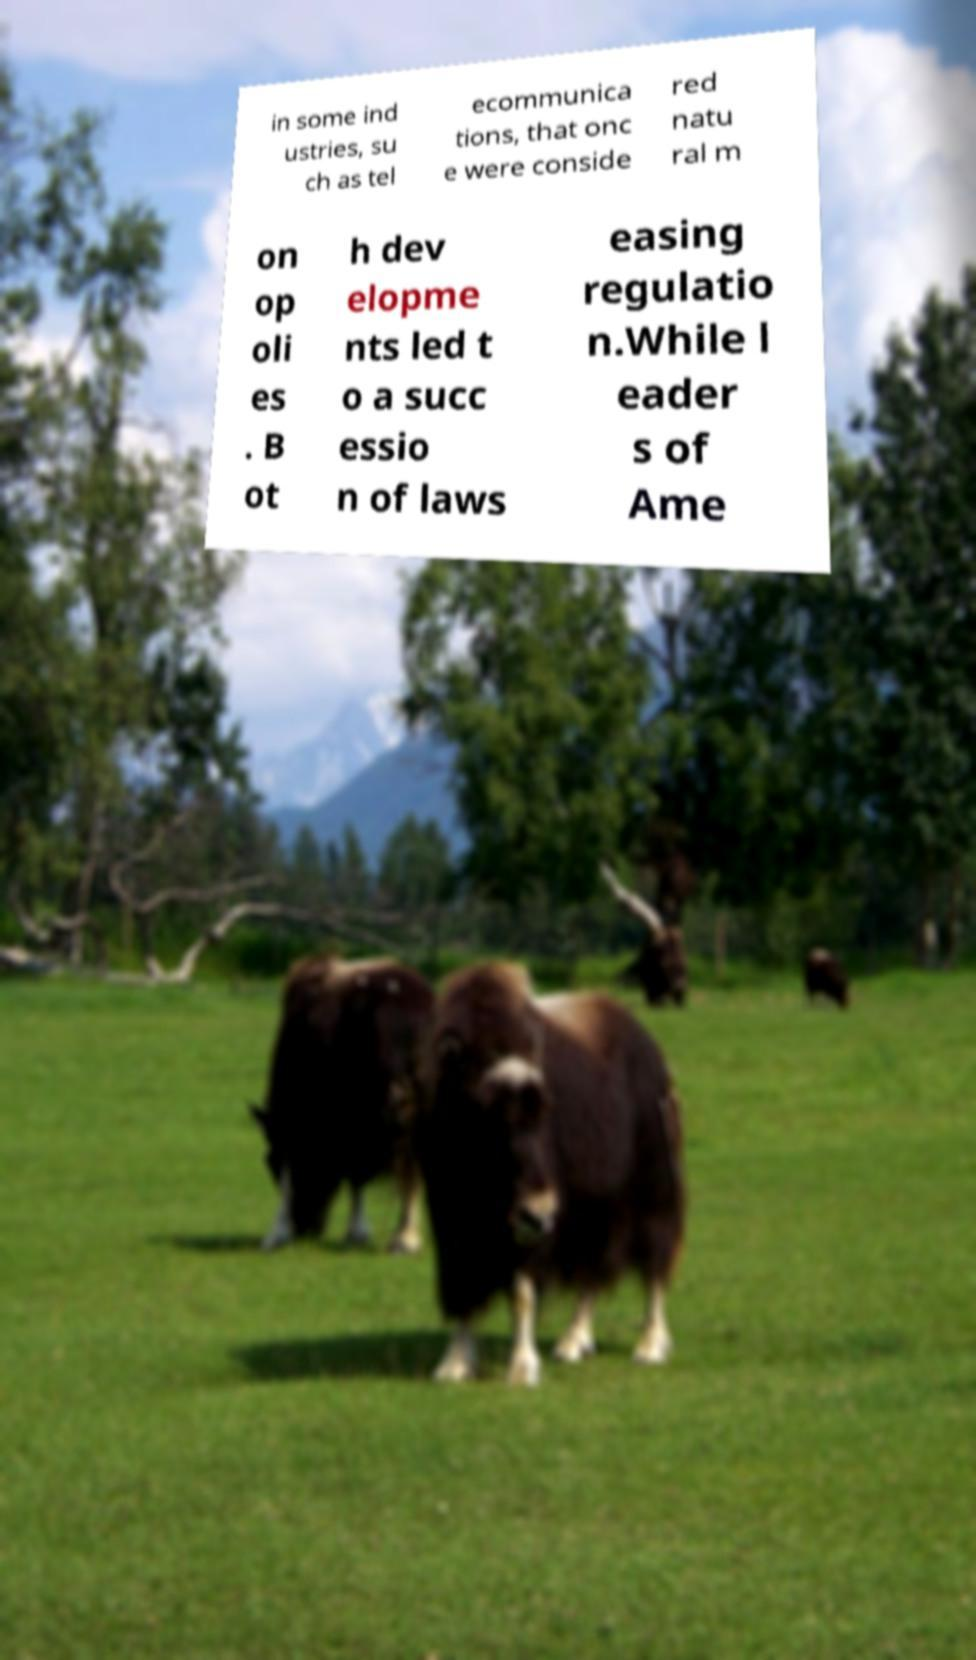There's text embedded in this image that I need extracted. Can you transcribe it verbatim? in some ind ustries, su ch as tel ecommunica tions, that onc e were conside red natu ral m on op oli es . B ot h dev elopme nts led t o a succ essio n of laws easing regulatio n.While l eader s of Ame 